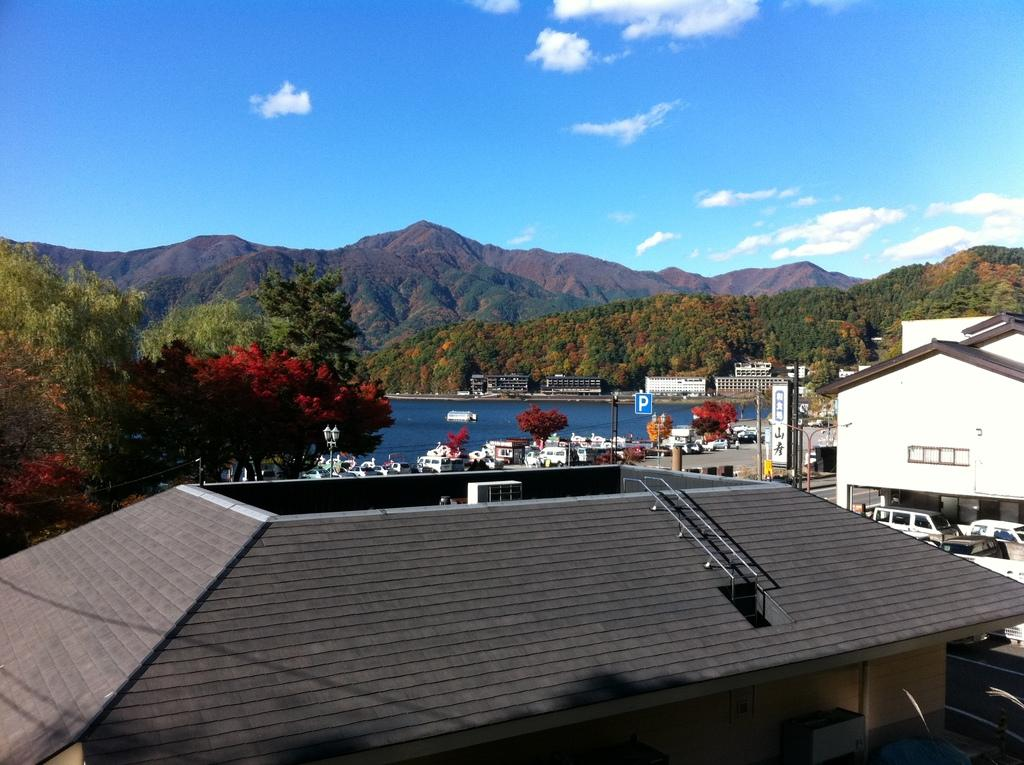What type of structures can be seen in the image? There are buildings in the image. What type of natural elements are present in the image? There are trees and water visible in the image. What type of man-made objects can be seen in the image? There are poles and boards in the image. What is visible in the background of the image? There are hills and sky visible in the background of the image. What can be seen in the sky? There are clouds in the sky. Can you tell me how many friends are sitting on the string in the image? There is no string or friends present in the image. What type of sun is shining in the image? There is no sun visible in the image; only clouds are present in the sky. 